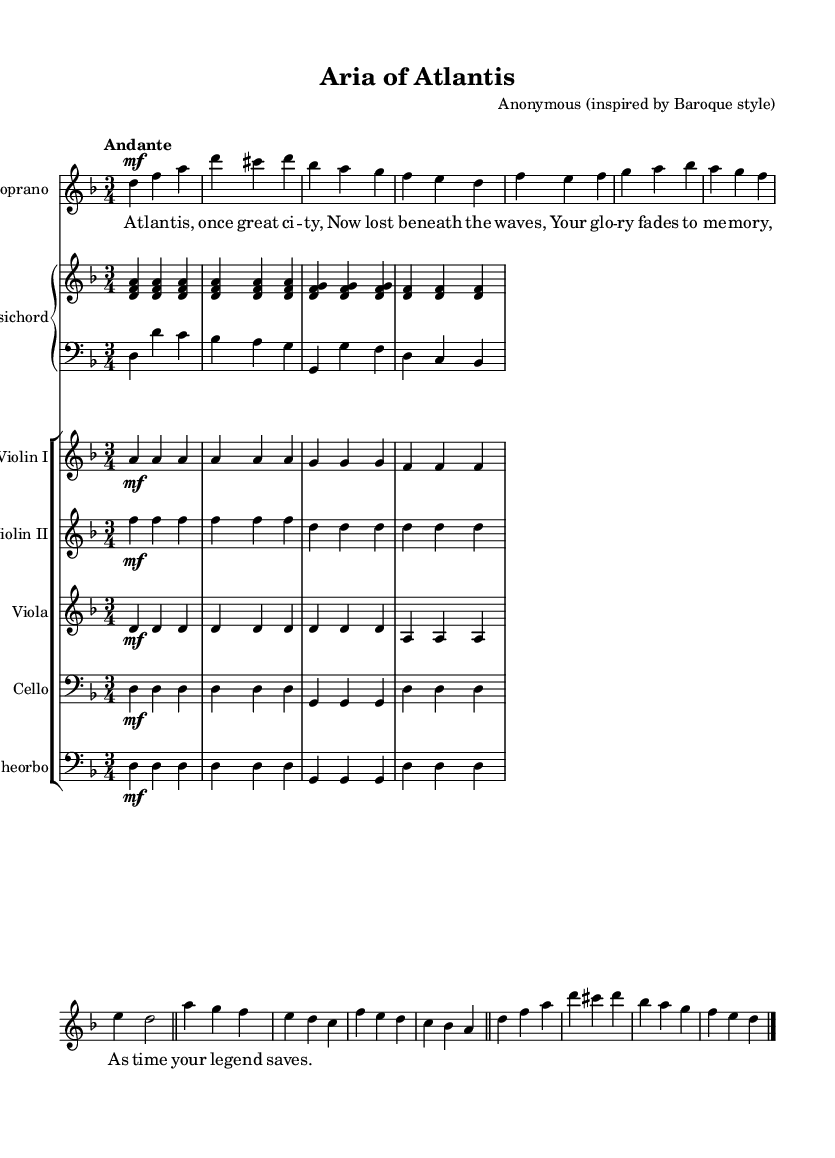What is the key signature of this music? The key signature is indicated at the beginning of the staff and shows one flat, which corresponds to D minor.
Answer: D minor What is the time signature of this music? The time signature is found at the beginning of the piece, indicating that there are three beats per measure.
Answer: 3/4 What is the tempo marking for this piece? The tempo marking "Andante" is written above the staff, suggesting a moderate walking pace.
Answer: Andante How many measures are in the A section of the aria? The A section consists of 4 measures as seen in the repeated melodic phrases.
Answer: 4 What type of text is set to the music, and what is the theme? The lyrics depict a narrative about Atlantis, specifically about its glory fading into memory, reflecting mythological themes.
Answer: Mythological Which instruments are included in the orchestration? The score includes strings (Violin I, Violin II, Viola, Cello) and a continuant (Theorbo), along with a solo Soprano.
Answer: Strings and Theorbo What is the dynamic marking for the soprano part throughout the aria? The dynamic marking is "mf", indicating the music should be performed moderately loud, which is consistent in the soprano part.
Answer: mf 